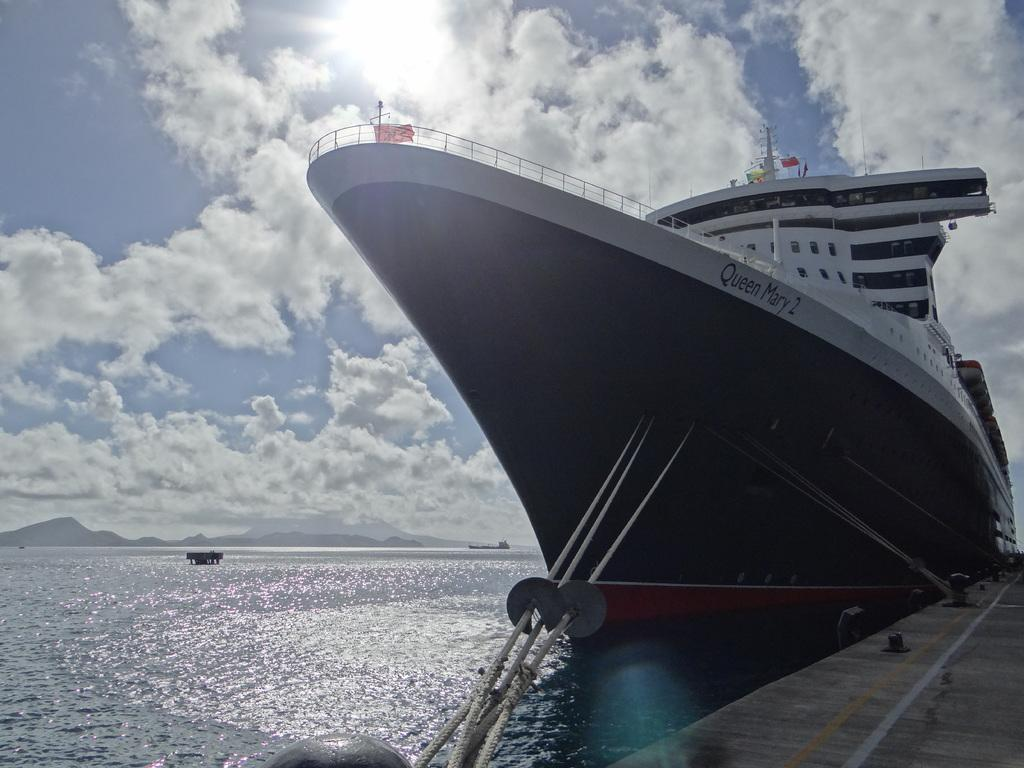What is the main subject of the image? The main subject of the image is a ship. Where is the ship located in the image? The ship is on water in the image. What other structures or features can be seen in the image? There is a platform and mountains visible in the image. What can be seen in the background of the image? The sky is visible in the background of the image, and clouds are present. How many bees can be seen flying around the ship in the image? There are no bees present in the image; it features a ship on water with a background of mountains, sky, and clouds. 